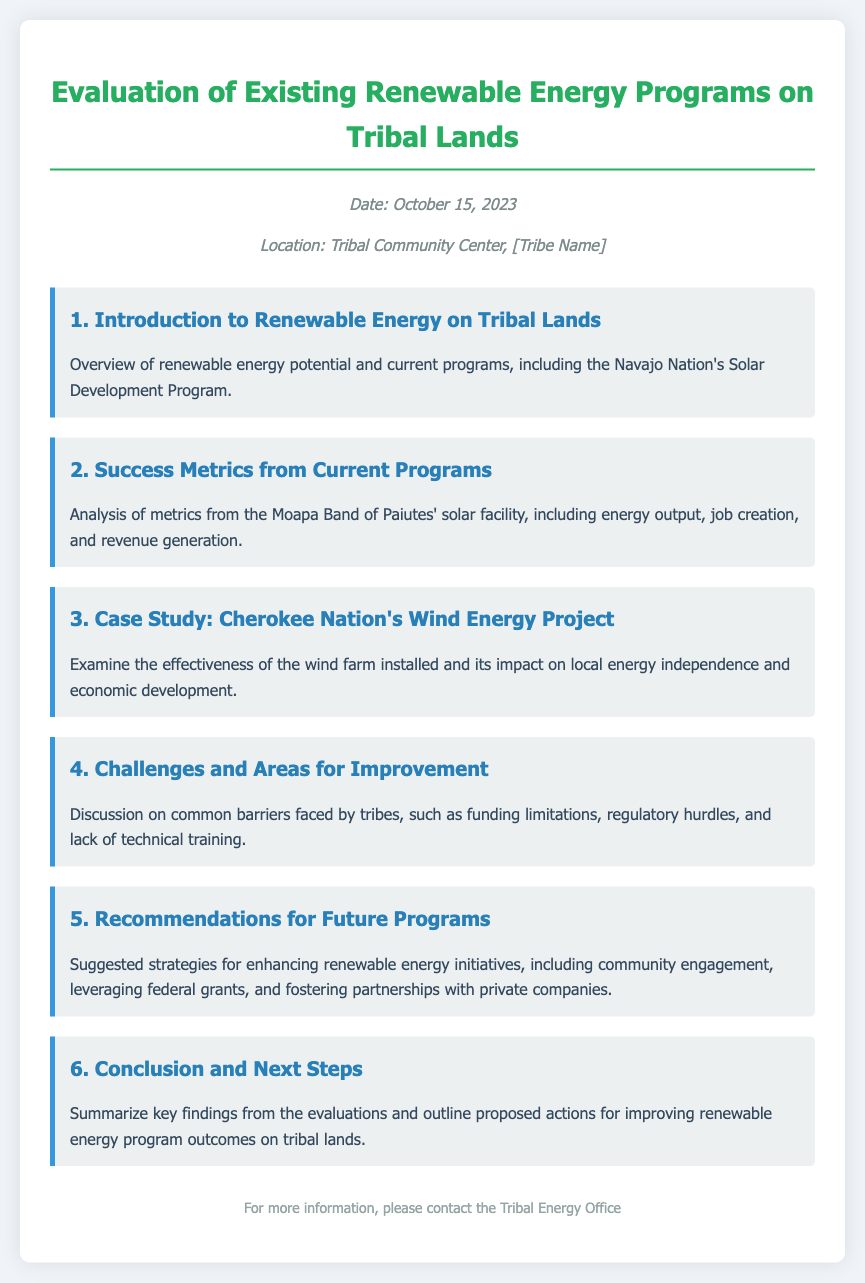What is the date of the meeting? The date is explicitly mentioned in the meeting information section of the document.
Answer: October 15, 2023 What program is highlighted in the introduction? The introduction mentions the program specifically, which sheds light on renewable energy initiatives in tribal lands.
Answer: Navajo Nation's Solar Development Program What metrics are analyzed from the Moapa Band of Paiutes? The document states specific metrics that are analyzed, indicating the criteria for evaluation.
Answer: Energy output, job creation, and revenue generation Which tribe's wind energy project is used as a case study? The case study section names the tribe whose wind energy project is evaluated, which helps to identify successful implementations.
Answer: Cherokee Nation What are some challenges mentioned in the document? The challenges section discusses common barriers which can aid in understanding the context of program limitations.
Answer: Funding limitations, regulatory hurdles, and lack of technical training What is one of the recommendations for future programs? The recommendations section offers strategies that may enhance future initiatives, providing guidance for policymakers.
Answer: Community engagement 